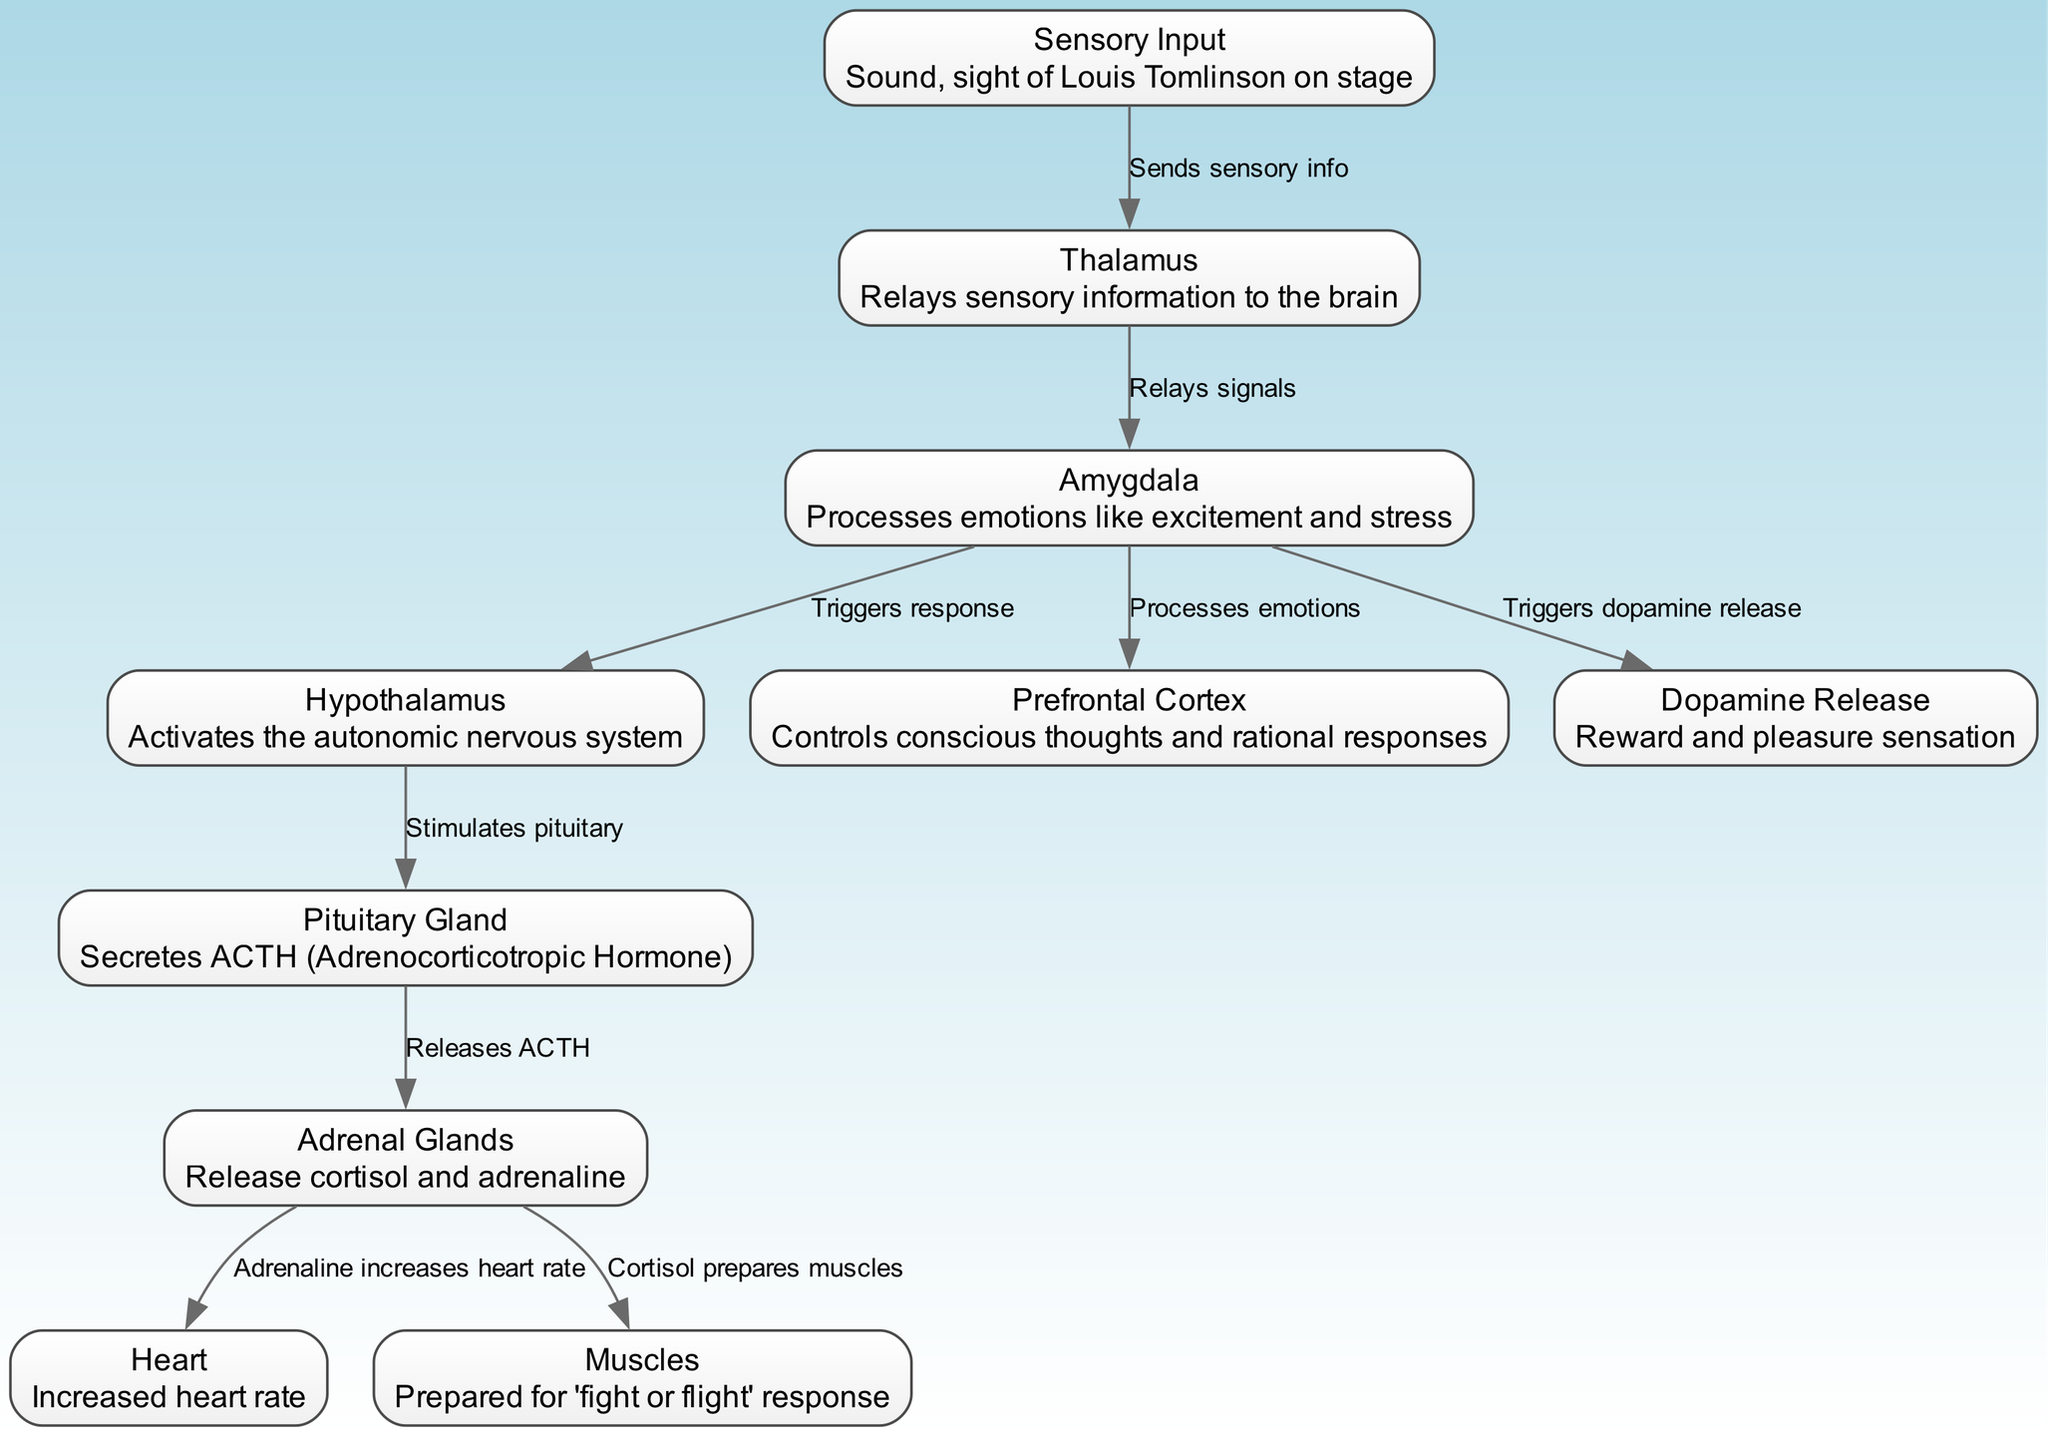What is the sensory input during a concert? The sensory input identified in the diagram includes the sound and sight of Louis Tomlinson on stage, mentioned in the "Sensory Input" node description.
Answer: Sound, sight of Louis Tomlinson on stage Which part of the brain relays sensory information? The Thalamus node is responsible for relaying sensory information to the brain, as shown in the diagram.
Answer: Thalamus How many nodes are there in the diagram? The diagram contains ten nodes, as indicated in the data provided.
Answer: 10 What triggers the stress response in the brain? The diagram shows that the Amygdala processes emotions like excitement and stress, triggering the stress response.
Answer: Amygdala What hormone is released by the Pituitary Gland? The Pituitary Gland secretes ACTH (Adrenocorticotropic Hormone), which is stated in its description in the diagram.
Answer: ACTH What effect does adrenaline have on the heart? According to the diagram, adrenaline increases heart rate, which is illustrated in the connection from Adrenal Glands to Heart.
Answer: Increases heart rate Which part of the brain is responsible for conscious thoughts? The Prefrontal Cortex node controls conscious thoughts and rational responses, as mentioned in its description.
Answer: Prefrontal Cortex What are the muscles prepared for in response to stress? The Cortisol release from Adrenal Glands prepares muscles for a 'fight or flight' response, indicated in the diagram.
Answer: 'Fight or flight' response Which node is involved in dopamine release? The diagram states that the Amygdala triggers dopamine release, indicating its involvement in the pleasure sensation during the concert.
Answer: Amygdala What does the hypothalamus activate? The Hypothalamus activates the autonomic nervous system, as noted in the diagram description for that node.
Answer: Autonomic nervous system 